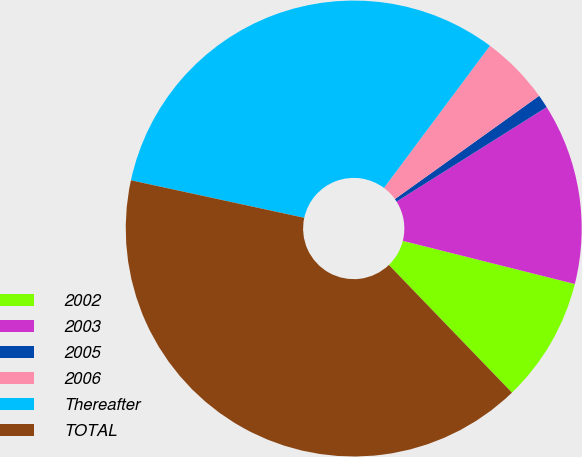<chart> <loc_0><loc_0><loc_500><loc_500><pie_chart><fcel>2002<fcel>2003<fcel>2005<fcel>2006<fcel>Thereafter<fcel>TOTAL<nl><fcel>8.88%<fcel>12.85%<fcel>0.95%<fcel>4.92%<fcel>31.8%<fcel>40.6%<nl></chart> 